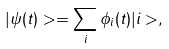<formula> <loc_0><loc_0><loc_500><loc_500>| \psi ( t ) > = \sum _ { i } \phi _ { i } ( t ) | i > ,</formula> 